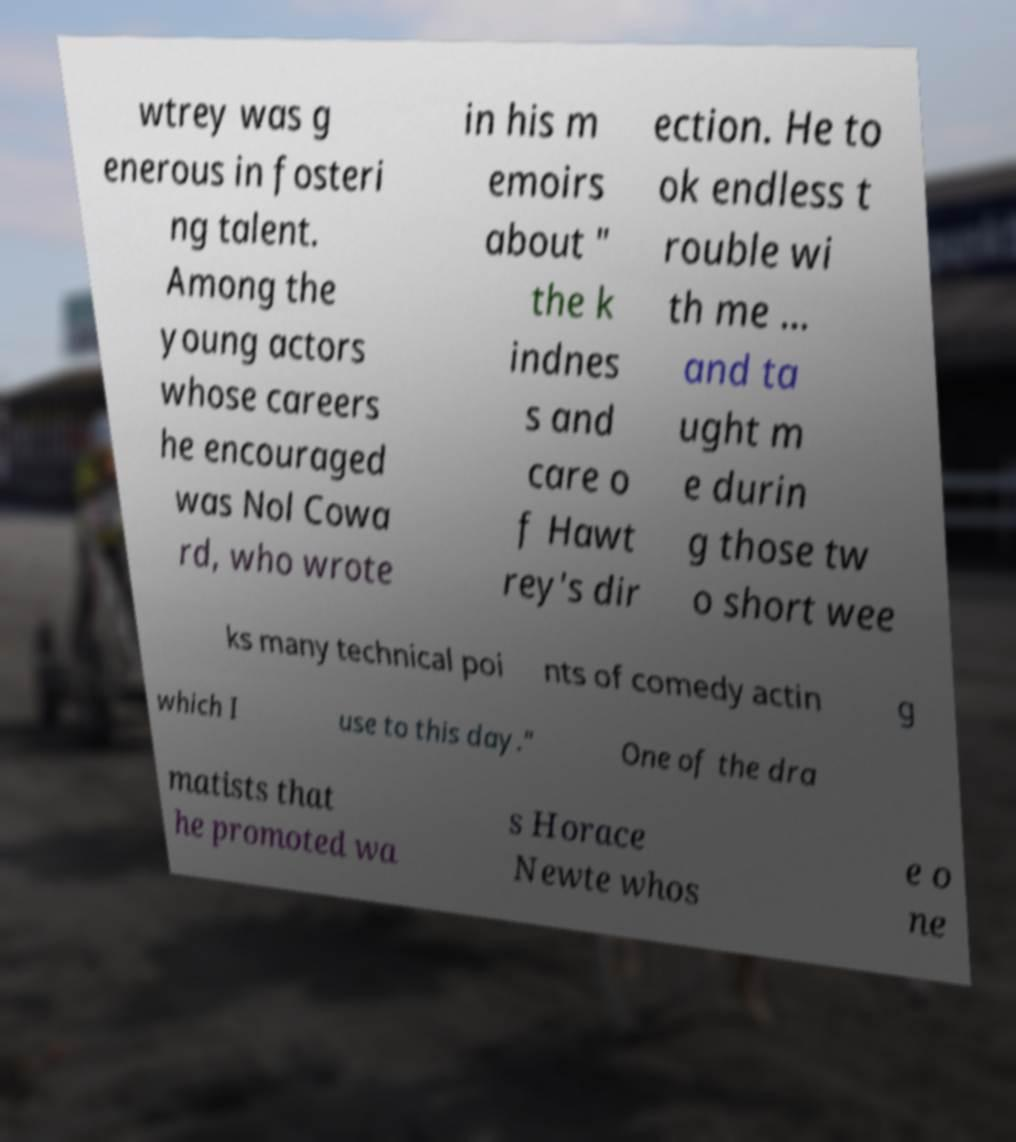I need the written content from this picture converted into text. Can you do that? wtrey was g enerous in fosteri ng talent. Among the young actors whose careers he encouraged was Nol Cowa rd, who wrote in his m emoirs about " the k indnes s and care o f Hawt rey's dir ection. He to ok endless t rouble wi th me ... and ta ught m e durin g those tw o short wee ks many technical poi nts of comedy actin g which I use to this day." One of the dra matists that he promoted wa s Horace Newte whos e o ne 